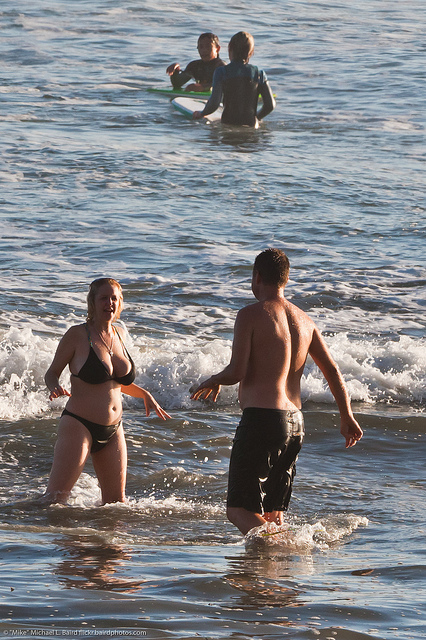How many people are swimming? While there are two individuals visible farther out in the water who appear to be swimming, the image also shows two other individuals closer to the shore who are standing in the shallows, presumably enjoying the water in a different way. 